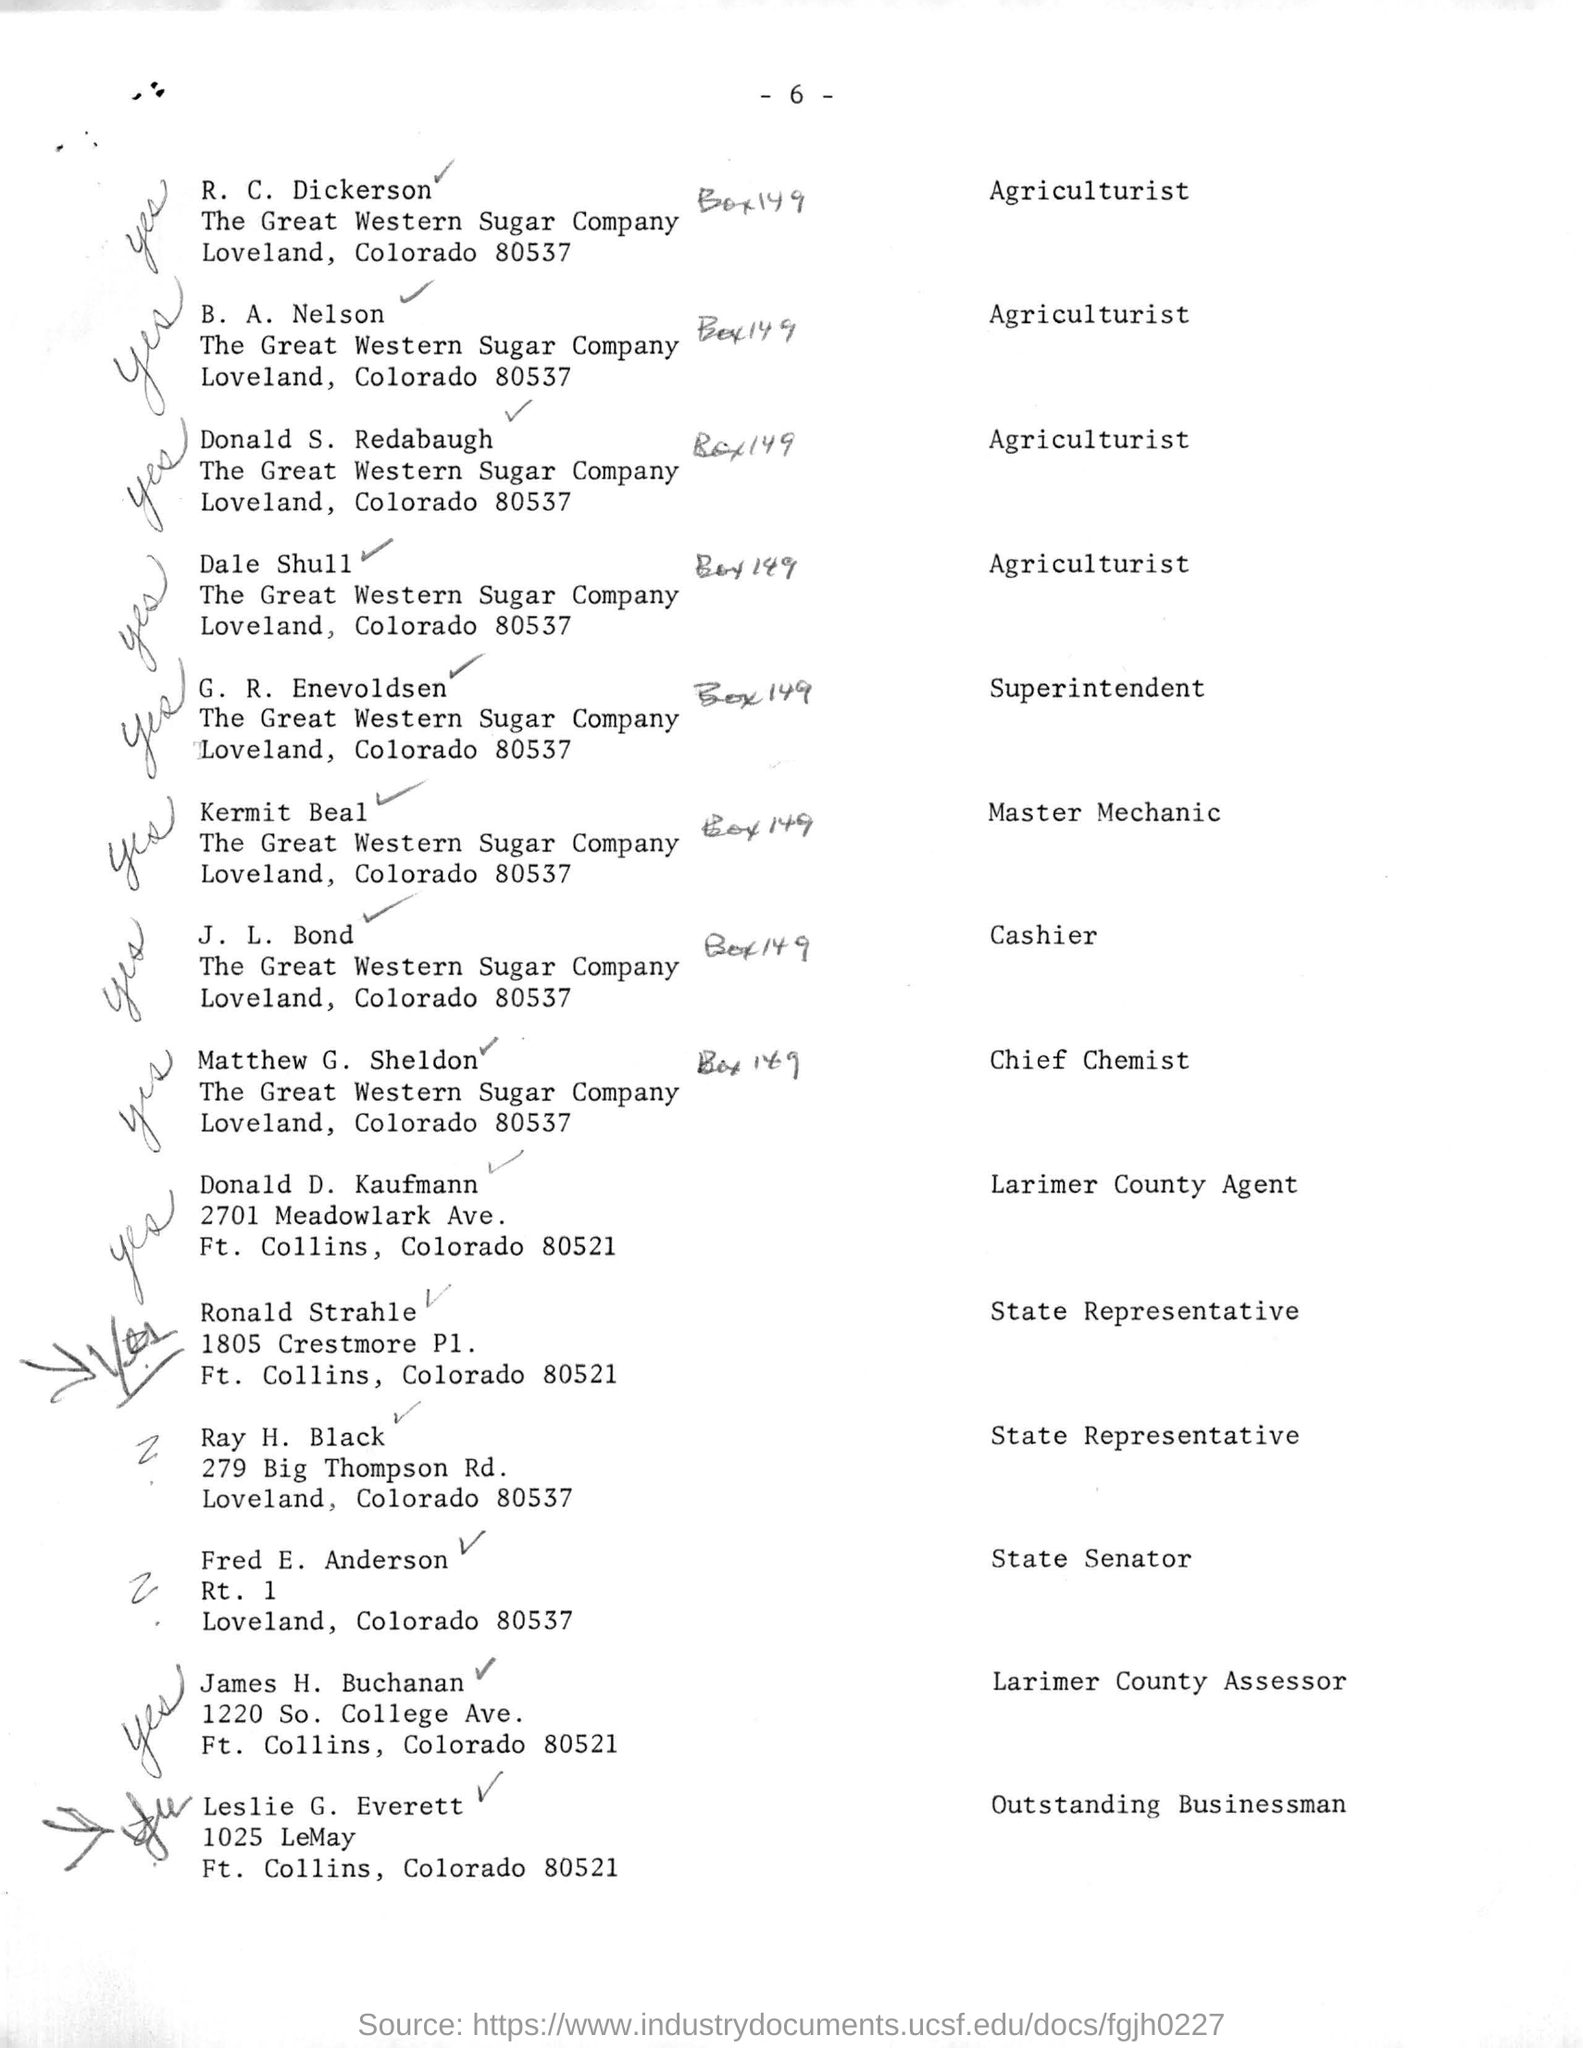What is the job title of R. C. Dickerson?
Keep it short and to the point. Agriculturist. What is the name of the person last on this list?
Keep it short and to the point. Leslie G. Everett. Who is mentioned as Superintendent?
Provide a short and direct response. G. R. Enevoldsen. Which is the person mentioned as Cashier?
Provide a succinct answer. J. L. Bond. 